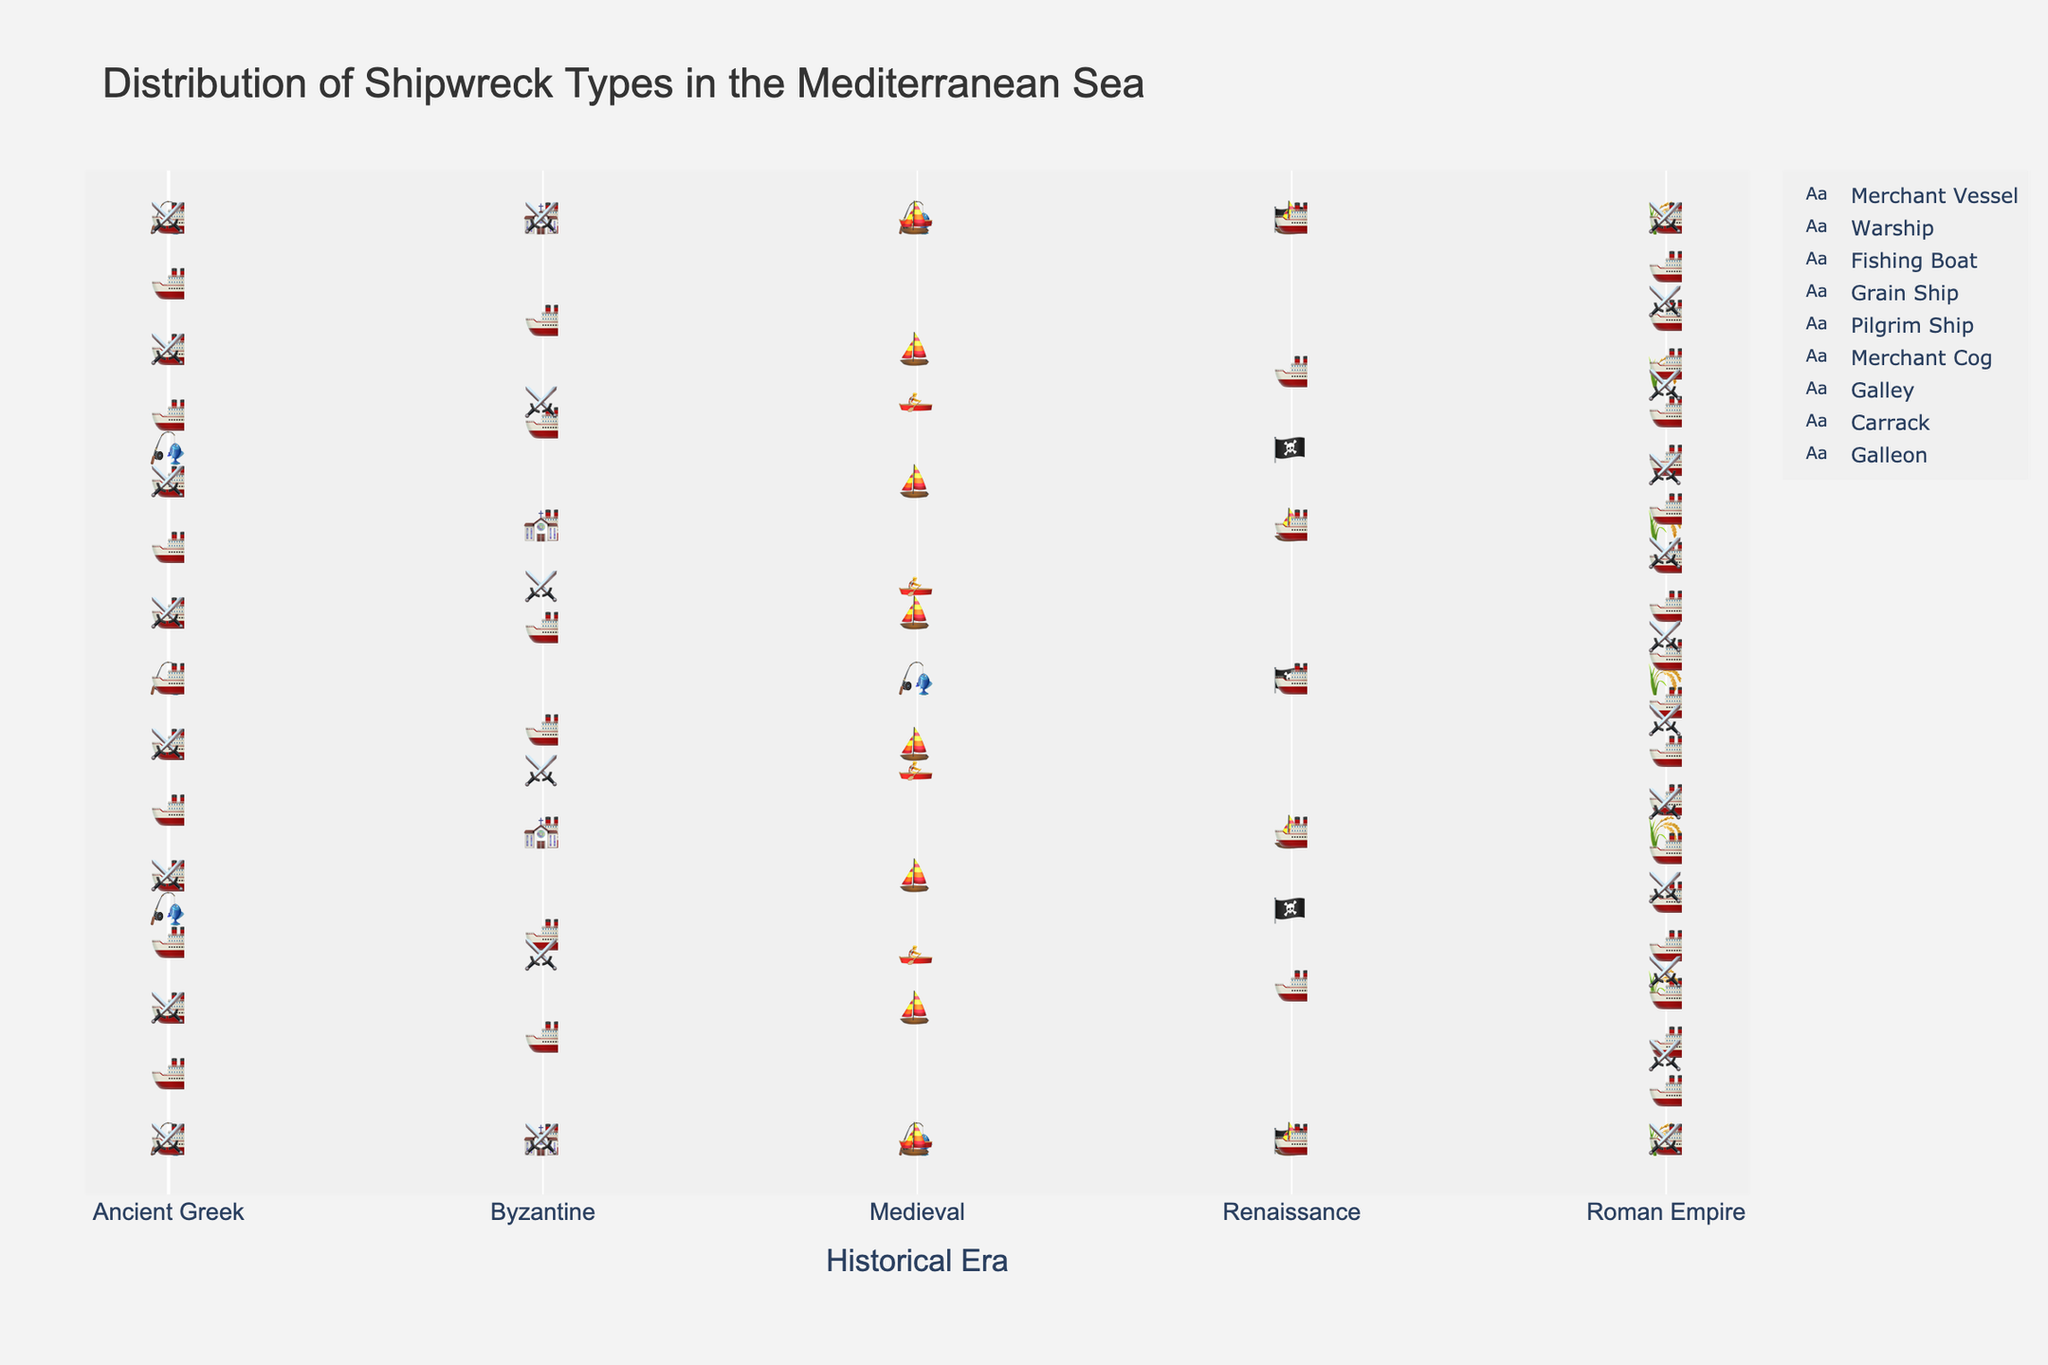What is the title of the plot? The title is usually found at the top of the plot. It provides a summary of what the plot is about.
Answer: Distribution of Shipwreck Types in the Mediterranean Sea Which era has the highest number of merchant vessels discovered? To find the era with the highest number of merchant vessels, look for the era with the most "🚢" icons. Count and compare across different eras.
Answer: Roman Empire Compare the number of warships from the Roman Empire with those from the Byzantine era. Which era has more? Look for the "⚔️" icons within the Roman Empire and Byzantine eras, then count how many there are in each era. Compare the totals.
Answer: Roman Empire How many shipwrecks of fishing boats were discovered in total? Sum the counts of the "🎣" icons across all eras (5 from Ancient Greek and 3 from Medieval). 5 + 3 = 8
Answer: 8 What is the most common type of shipwreck discovered from the Ancient Greek era? Look at the icons in the Ancient Greek era and count which type appears the most frequently.
Answer: Merchant Vessel Which era has the least diverse types of shipwrecks discovered? Count the number of different icons (representing different ship types) in each era. The era with the fewest different icons is the least diverse.
Answer: Byzantine If you add the number of warships and grain ships from the Roman Empire, what is the total? Count the "⚔️" icons and "🌾" icons within the Roman Empire era, then add the counts together. 12 (warships) + 7 (grain ships) = 19
Answer: 19 Which type of shipwreck appears only in one era and not in any other? Look for icons that are unique to a single era and not repeated elsewhere in the plot.
Answer: Pilgrim Ship, Grain Ship, Merchant Cog, Galley, Carrack, Galleon Does the Medieval era have more or fewer shipwrecks overall compared to the Byzantine era? Sum the counts of all ship types in the Medieval and Byzantine eras respectively, then compare the totals. 8 (Merchant Cog) + 6 (Galley) + 3 (Fishing Boat) = 17 for Medieval. 10 (Merchant Vessel) + 6 (Warship) + 4 (Pilgrim Ship) = 20 for Byzantine.
Answer: Fewer Which ship type has the highest number of shipwrecks in total across all eras? Count the total number of each type of icon across all eras and identify which type has the most.
Answer: Merchant Vessel 